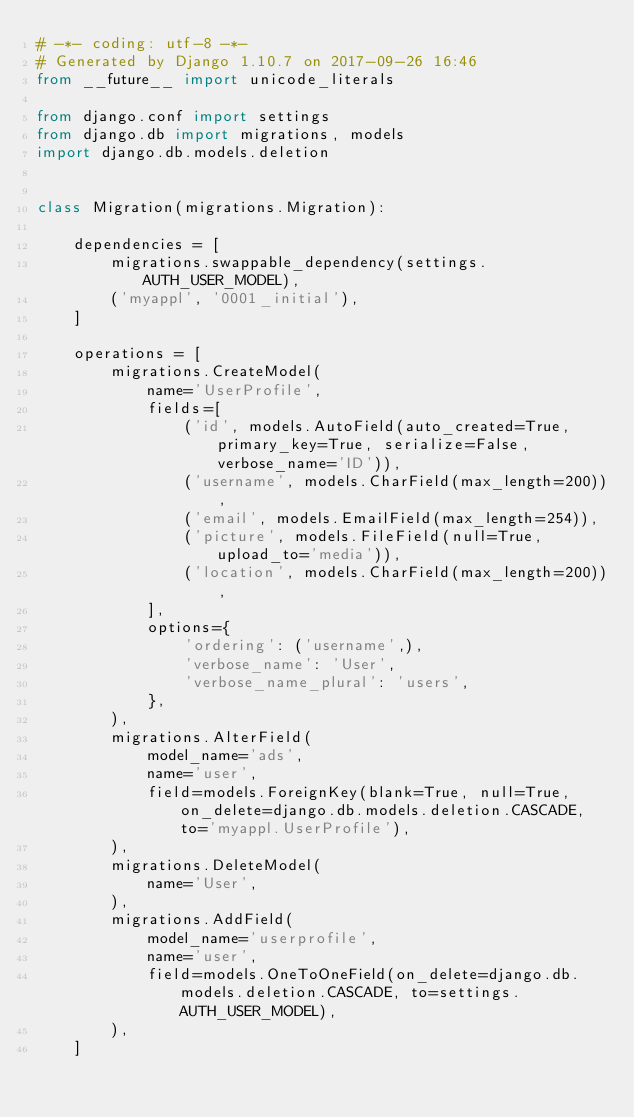<code> <loc_0><loc_0><loc_500><loc_500><_Python_># -*- coding: utf-8 -*-
# Generated by Django 1.10.7 on 2017-09-26 16:46
from __future__ import unicode_literals

from django.conf import settings
from django.db import migrations, models
import django.db.models.deletion


class Migration(migrations.Migration):

    dependencies = [
        migrations.swappable_dependency(settings.AUTH_USER_MODEL),
        ('myappl', '0001_initial'),
    ]

    operations = [
        migrations.CreateModel(
            name='UserProfile',
            fields=[
                ('id', models.AutoField(auto_created=True, primary_key=True, serialize=False, verbose_name='ID')),
                ('username', models.CharField(max_length=200)),
                ('email', models.EmailField(max_length=254)),
                ('picture', models.FileField(null=True, upload_to='media')),
                ('location', models.CharField(max_length=200)),
            ],
            options={
                'ordering': ('username',),
                'verbose_name': 'User',
                'verbose_name_plural': 'users',
            },
        ),
        migrations.AlterField(
            model_name='ads',
            name='user',
            field=models.ForeignKey(blank=True, null=True, on_delete=django.db.models.deletion.CASCADE, to='myappl.UserProfile'),
        ),
        migrations.DeleteModel(
            name='User',
        ),
        migrations.AddField(
            model_name='userprofile',
            name='user',
            field=models.OneToOneField(on_delete=django.db.models.deletion.CASCADE, to=settings.AUTH_USER_MODEL),
        ),
    ]
</code> 